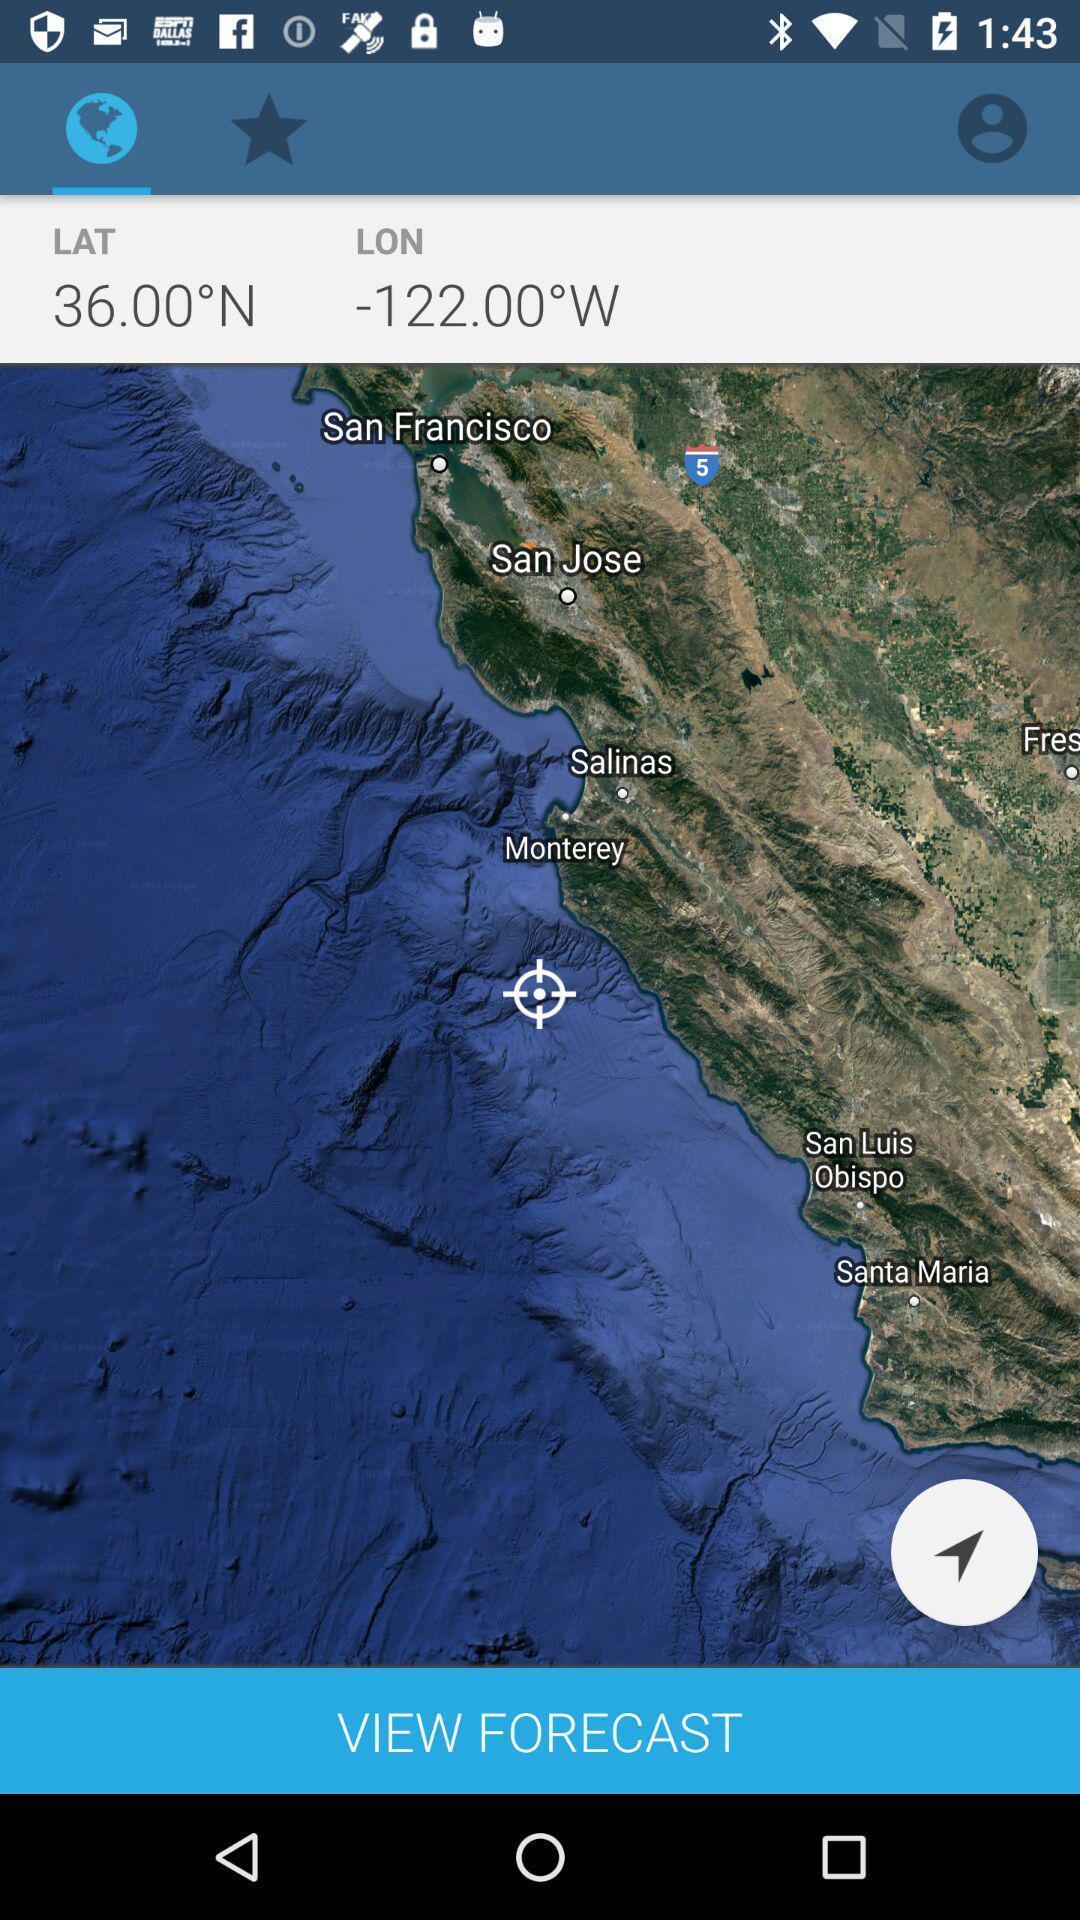Please provide a description for this image. Page displaying the maps. 